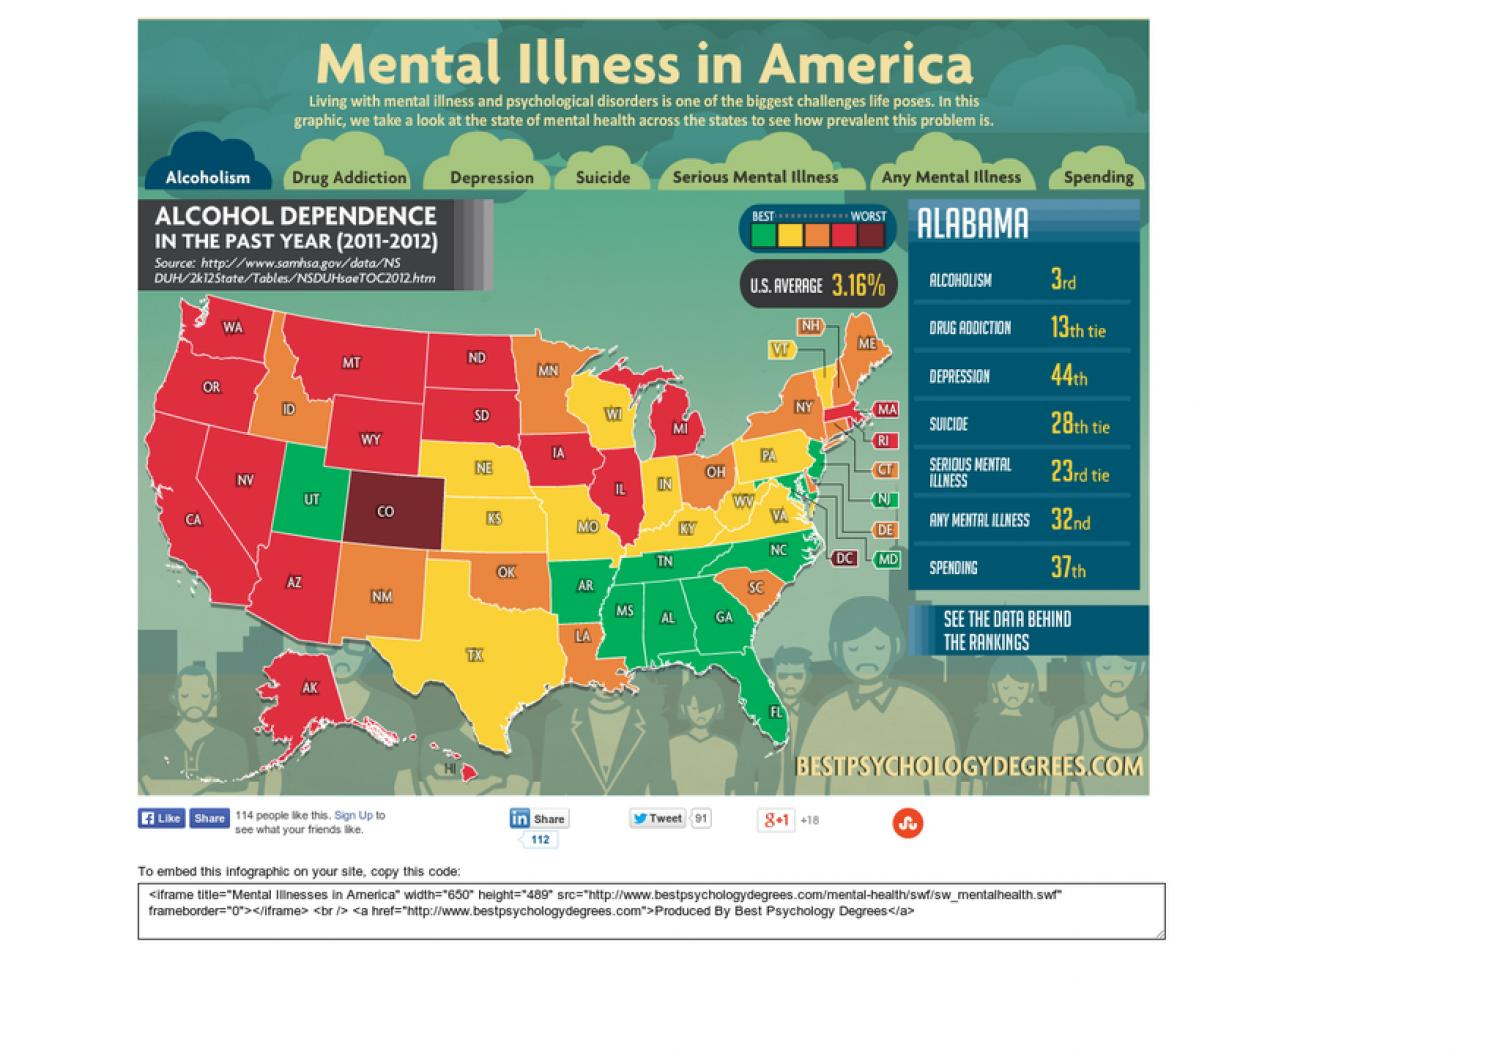Mention a couple of crucial points in this snapshot. The document states that alcoholism is the main cause of mental illness. The best number of states for alcohol dependence during the years 2011-2012 is 10. 